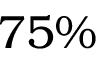<formula> <loc_0><loc_0><loc_500><loc_500>7 5 \%</formula> 